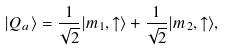Convert formula to latex. <formula><loc_0><loc_0><loc_500><loc_500>| Q _ { a } \rangle = \frac { 1 } { \sqrt { 2 } } | m _ { 1 } , \uparrow \rangle + \frac { 1 } { \sqrt { 2 } } | m _ { 2 } , \uparrow \rangle ,</formula> 